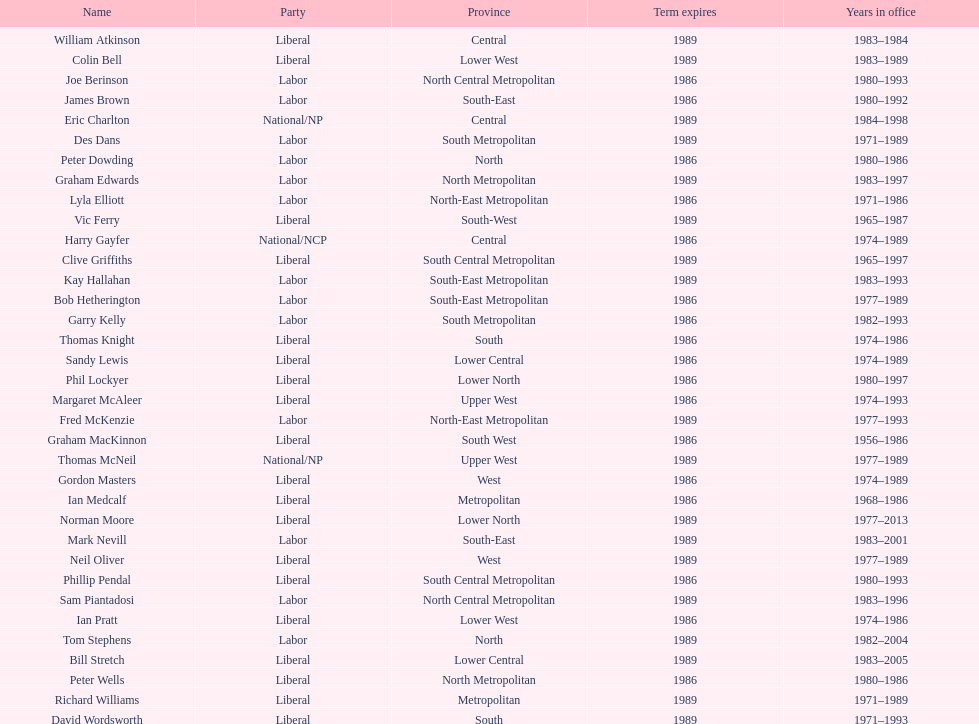State the most recent member listed with a family name beginning with "p". Ian Pratt. 